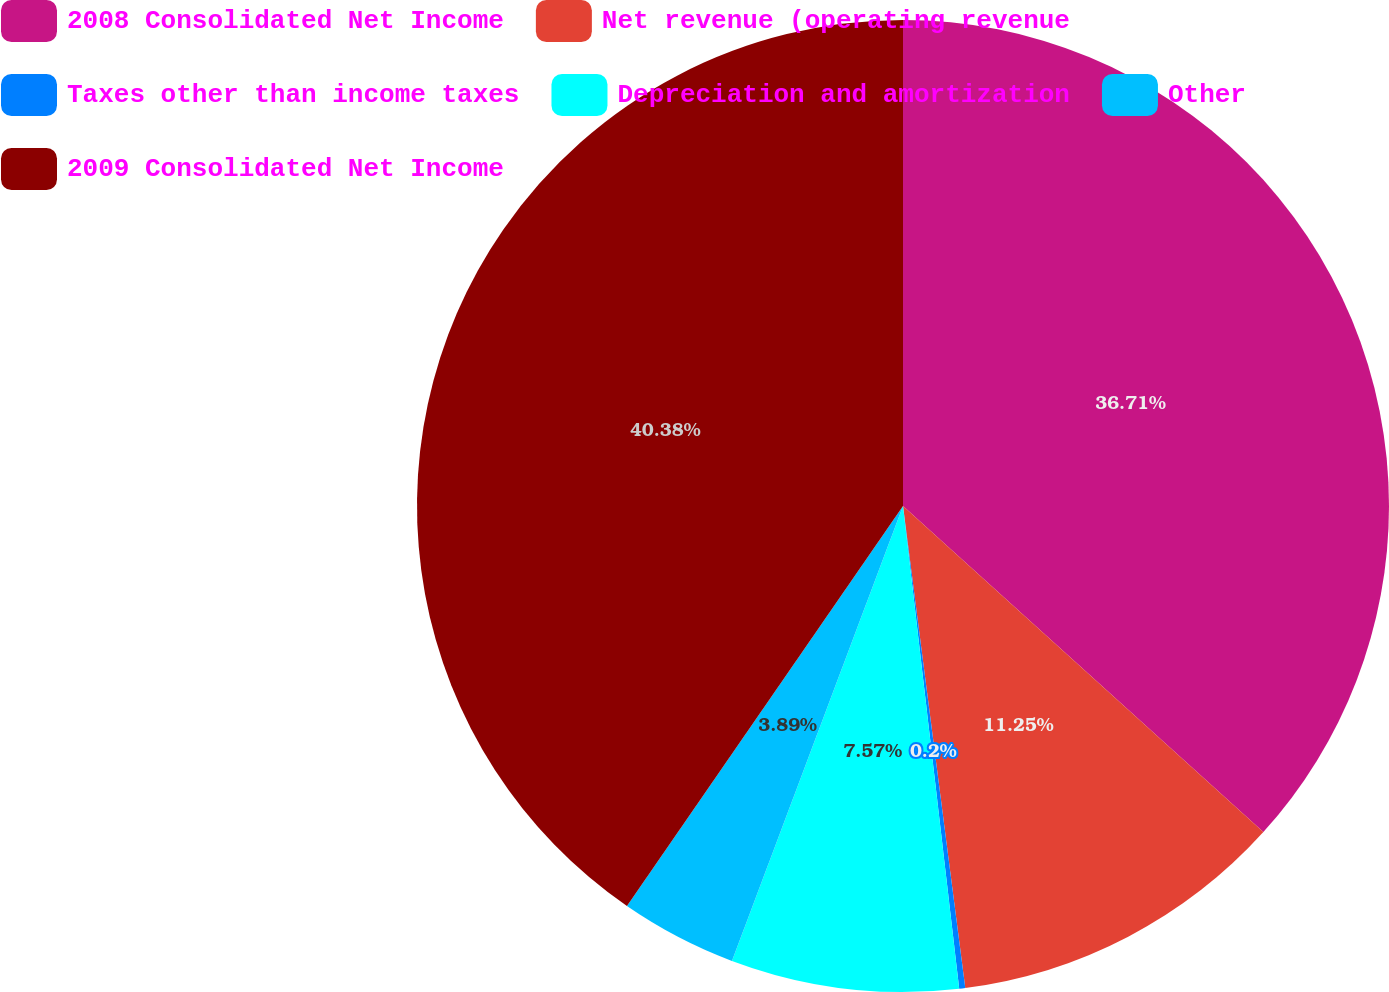Convert chart to OTSL. <chart><loc_0><loc_0><loc_500><loc_500><pie_chart><fcel>2008 Consolidated Net Income<fcel>Net revenue (operating revenue<fcel>Taxes other than income taxes<fcel>Depreciation and amortization<fcel>Other<fcel>2009 Consolidated Net Income<nl><fcel>36.71%<fcel>11.25%<fcel>0.2%<fcel>7.57%<fcel>3.89%<fcel>40.39%<nl></chart> 